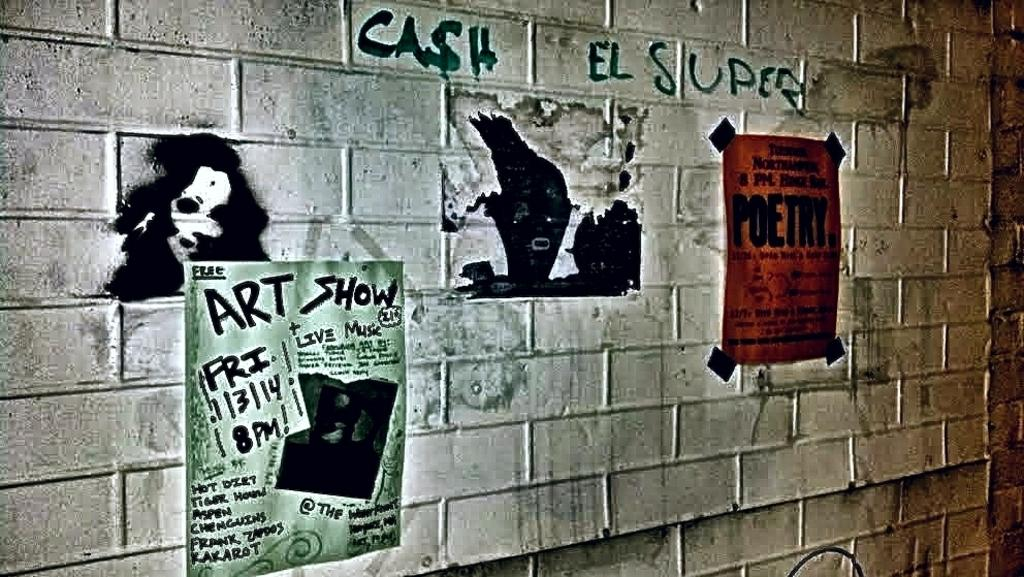What is present on the wall in the image? There are two posters, some painting, and some text on the wall in the image. Can you describe the posters on the wall? Unfortunately, the specific details of the posters cannot be determined from the provided facts. What type of painting is on the wall? The facts only mention that there is some painting on the wall, but the specific style or subject cannot be determined. What does the text on the wall say? The facts do not provide any information about the content of the text on the wall. What type of government is depicted in the shop on the wall? There is no shop present in the image, and therefore no government can be depicted. 